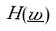Convert formula to latex. <formula><loc_0><loc_0><loc_500><loc_500>H ( \underline { w } )</formula> 